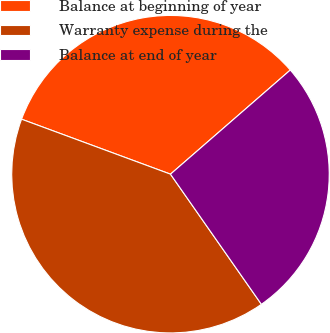Convert chart to OTSL. <chart><loc_0><loc_0><loc_500><loc_500><pie_chart><fcel>Balance at beginning of year<fcel>Warranty expense during the<fcel>Balance at end of year<nl><fcel>32.98%<fcel>40.33%<fcel>26.68%<nl></chart> 